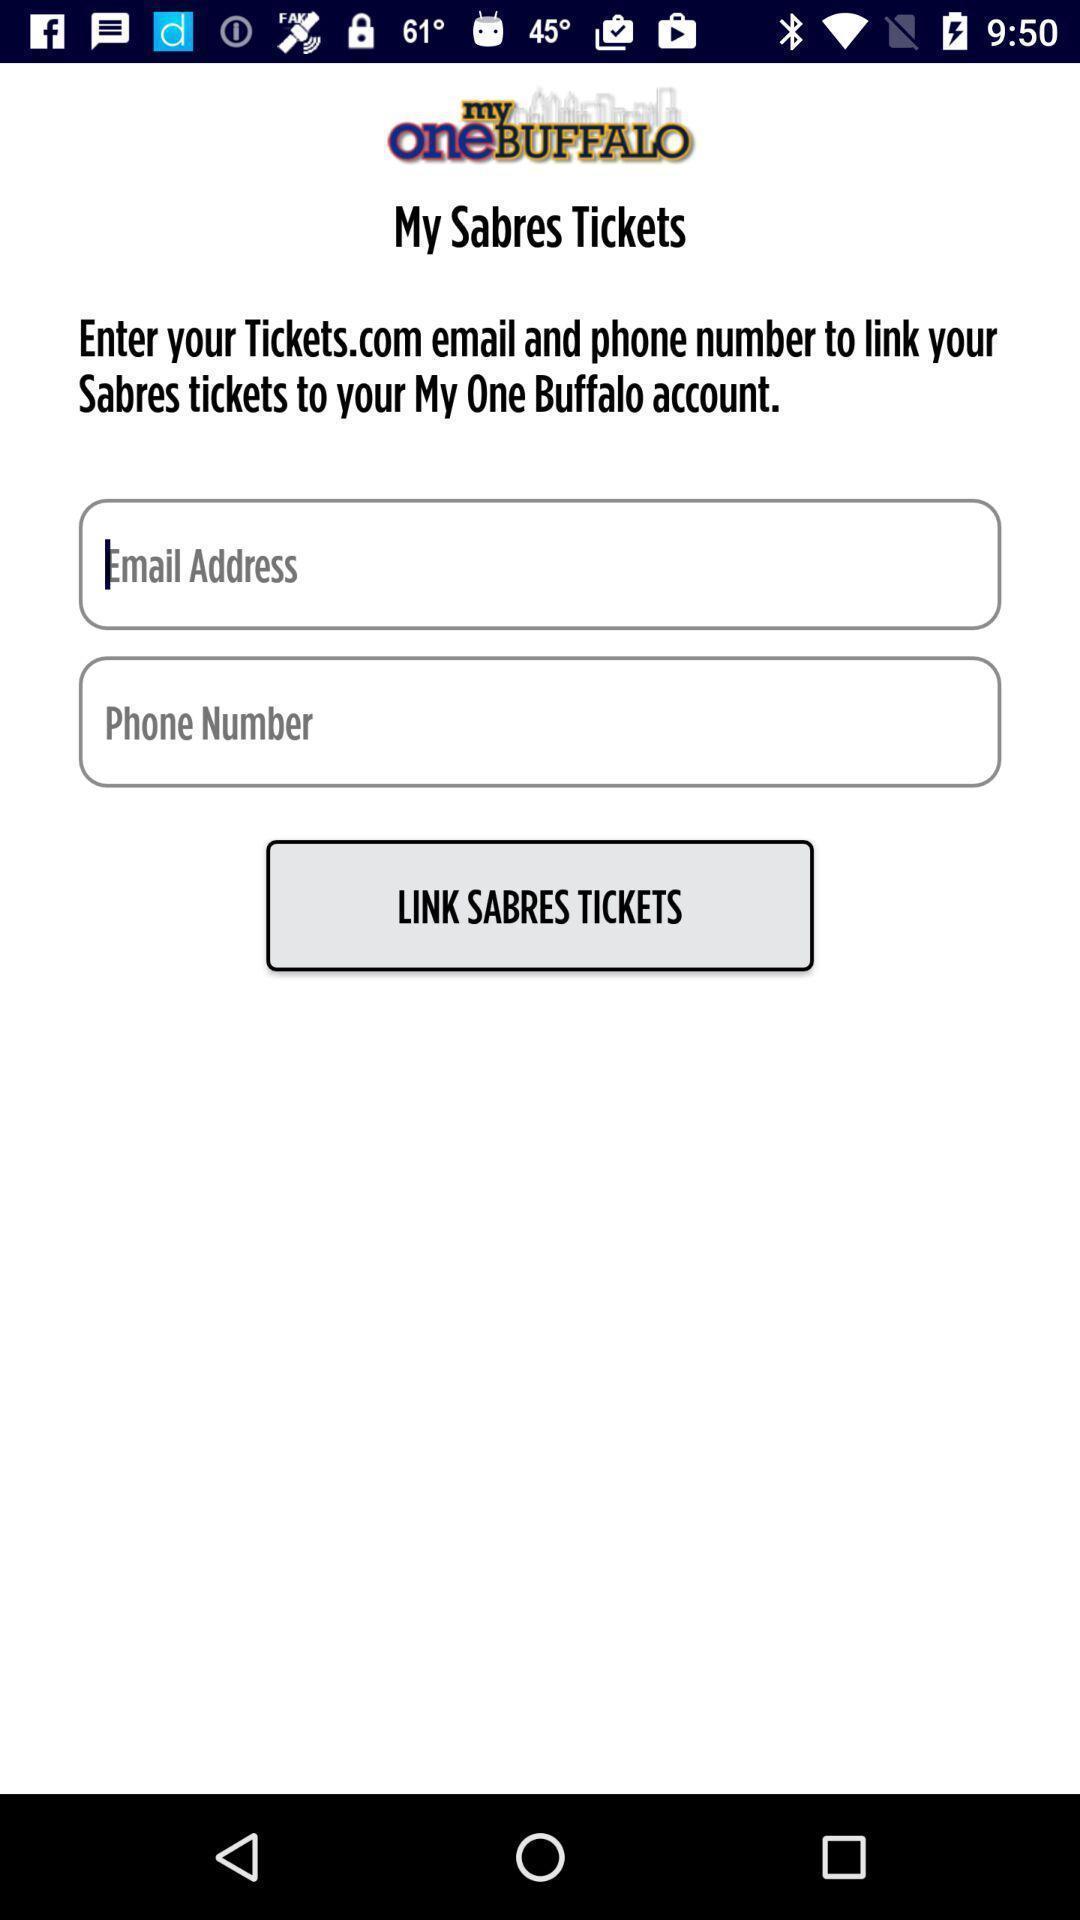Summarize the information in this screenshot. Screen showing the input login credentials page. 